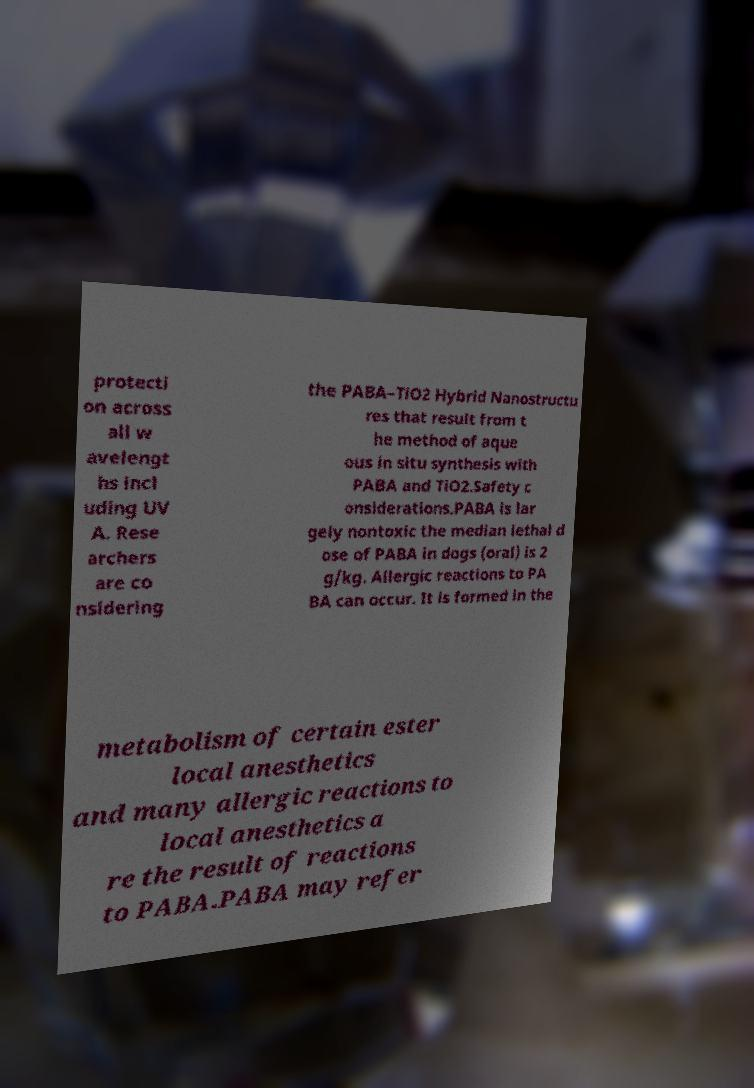Can you read and provide the text displayed in the image?This photo seems to have some interesting text. Can you extract and type it out for me? protecti on across all w avelengt hs incl uding UV A. Rese archers are co nsidering the PABA–TiO2 Hybrid Nanostructu res that result from t he method of aque ous in situ synthesis with PABA and TiO2.Safety c onsiderations.PABA is lar gely nontoxic the median lethal d ose of PABA in dogs (oral) is 2 g/kg. Allergic reactions to PA BA can occur. It is formed in the metabolism of certain ester local anesthetics and many allergic reactions to local anesthetics a re the result of reactions to PABA.PABA may refer 